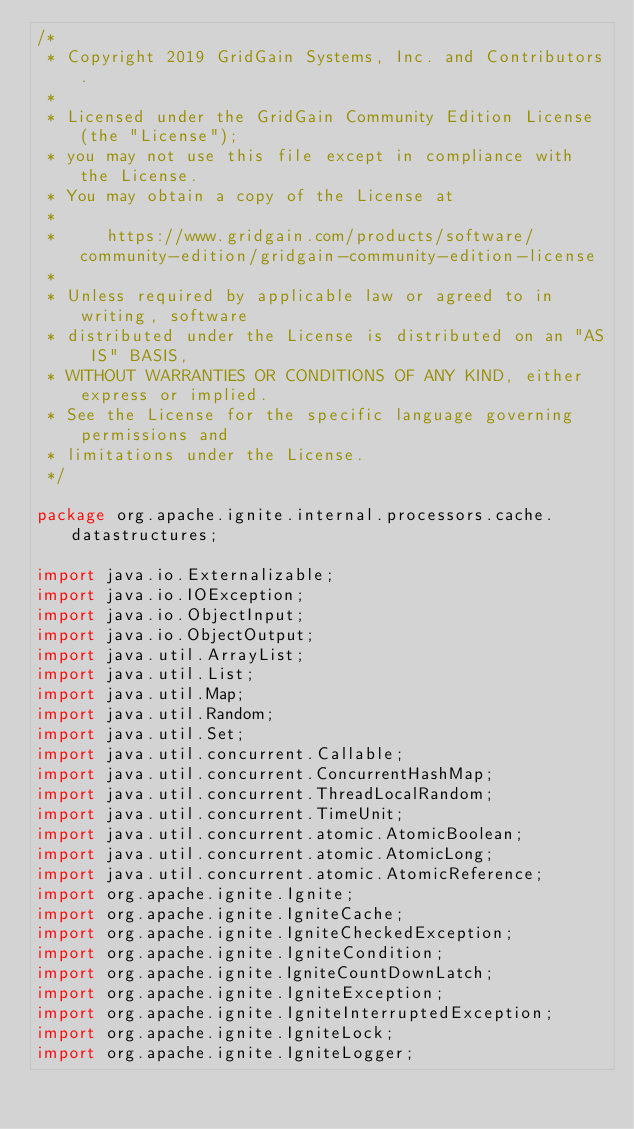Convert code to text. <code><loc_0><loc_0><loc_500><loc_500><_Java_>/*
 * Copyright 2019 GridGain Systems, Inc. and Contributors.
 *
 * Licensed under the GridGain Community Edition License (the "License");
 * you may not use this file except in compliance with the License.
 * You may obtain a copy of the License at
 *
 *     https://www.gridgain.com/products/software/community-edition/gridgain-community-edition-license
 *
 * Unless required by applicable law or agreed to in writing, software
 * distributed under the License is distributed on an "AS IS" BASIS,
 * WITHOUT WARRANTIES OR CONDITIONS OF ANY KIND, either express or implied.
 * See the License for the specific language governing permissions and
 * limitations under the License.
 */

package org.apache.ignite.internal.processors.cache.datastructures;

import java.io.Externalizable;
import java.io.IOException;
import java.io.ObjectInput;
import java.io.ObjectOutput;
import java.util.ArrayList;
import java.util.List;
import java.util.Map;
import java.util.Random;
import java.util.Set;
import java.util.concurrent.Callable;
import java.util.concurrent.ConcurrentHashMap;
import java.util.concurrent.ThreadLocalRandom;
import java.util.concurrent.TimeUnit;
import java.util.concurrent.atomic.AtomicBoolean;
import java.util.concurrent.atomic.AtomicLong;
import java.util.concurrent.atomic.AtomicReference;
import org.apache.ignite.Ignite;
import org.apache.ignite.IgniteCache;
import org.apache.ignite.IgniteCheckedException;
import org.apache.ignite.IgniteCondition;
import org.apache.ignite.IgniteCountDownLatch;
import org.apache.ignite.IgniteException;
import org.apache.ignite.IgniteInterruptedException;
import org.apache.ignite.IgniteLock;
import org.apache.ignite.IgniteLogger;</code> 